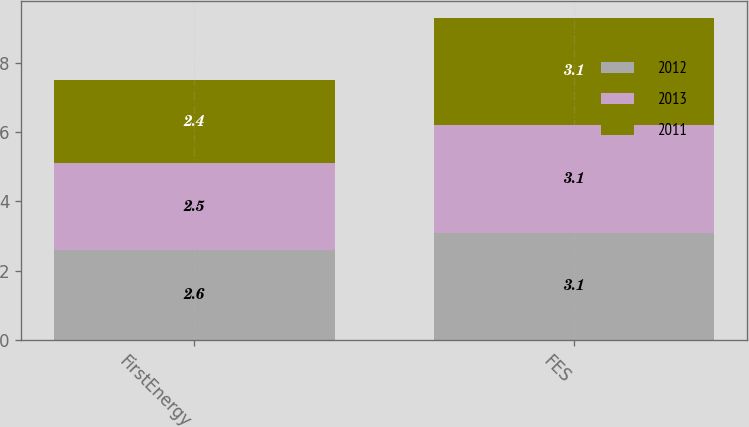<chart> <loc_0><loc_0><loc_500><loc_500><stacked_bar_chart><ecel><fcel>FirstEnergy<fcel>FES<nl><fcel>2012<fcel>2.6<fcel>3.1<nl><fcel>2013<fcel>2.5<fcel>3.1<nl><fcel>2011<fcel>2.4<fcel>3.1<nl></chart> 